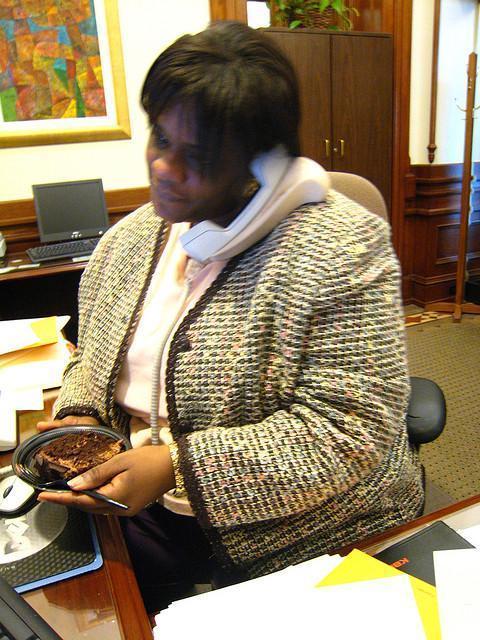Is "The cake is at the left side of the person." an appropriate description for the image?
Answer yes or no. Yes. Is this affirmation: "The cake is across from the person." correct?
Answer yes or no. No. 